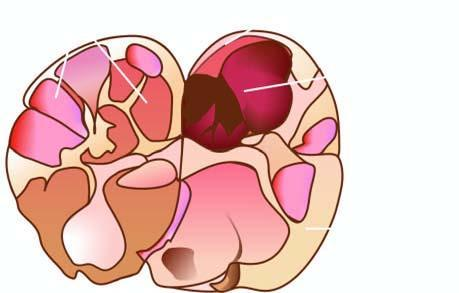what shows a solitary nodule having capsule?
Answer the question using a single word or phrase. Sectioned surface of the thyroid 